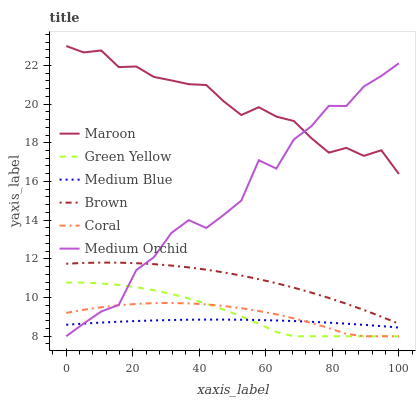Does Medium Blue have the minimum area under the curve?
Answer yes or no. Yes. Does Maroon have the maximum area under the curve?
Answer yes or no. Yes. Does Coral have the minimum area under the curve?
Answer yes or no. No. Does Coral have the maximum area under the curve?
Answer yes or no. No. Is Medium Blue the smoothest?
Answer yes or no. Yes. Is Medium Orchid the roughest?
Answer yes or no. Yes. Is Coral the smoothest?
Answer yes or no. No. Is Coral the roughest?
Answer yes or no. No. Does Medium Blue have the lowest value?
Answer yes or no. No. Does Coral have the highest value?
Answer yes or no. No. Is Medium Blue less than Brown?
Answer yes or no. Yes. Is Maroon greater than Brown?
Answer yes or no. Yes. Does Medium Blue intersect Brown?
Answer yes or no. No. 